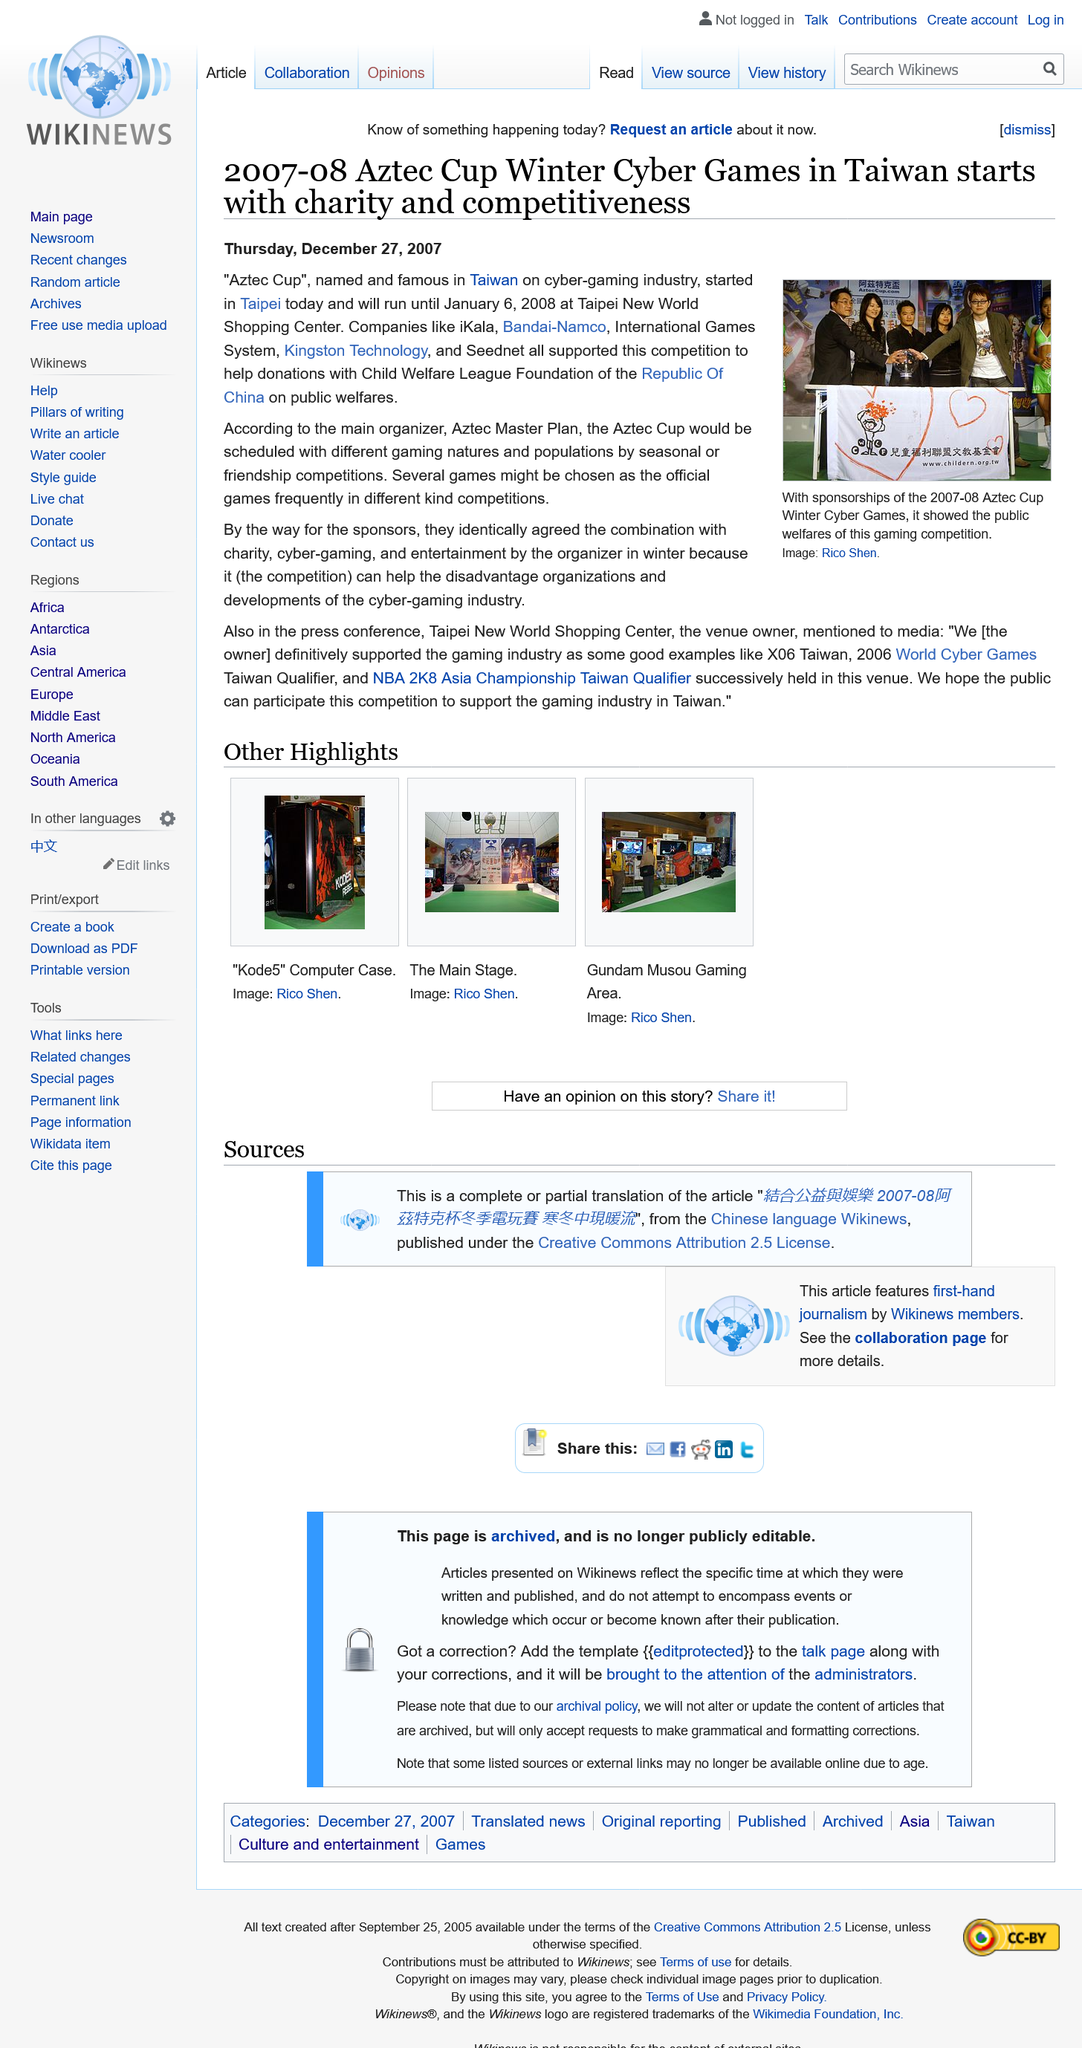Highlight a few significant elements in this photo. The competition was hosted in winter for the reason that it provided an opportunity for disadvantaged organizations to participate and contribute to the growth and development of the cyber-gaming industry. The Aztec Cup, a prestigious international taekwondo tournament, began in Taipei. The proceeds from the Aztec Cup, which benefited child welfare in China, were derived from donations. 